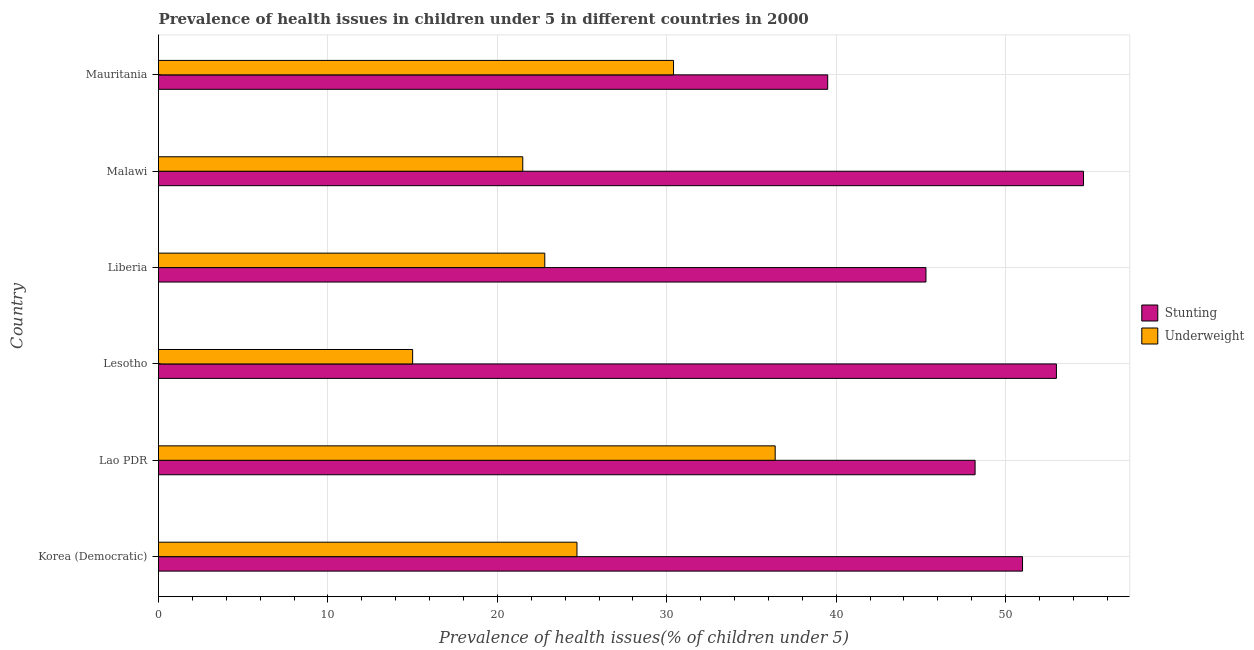How many different coloured bars are there?
Keep it short and to the point. 2. Are the number of bars per tick equal to the number of legend labels?
Offer a terse response. Yes. Are the number of bars on each tick of the Y-axis equal?
Your response must be concise. Yes. How many bars are there on the 4th tick from the bottom?
Offer a terse response. 2. What is the label of the 5th group of bars from the top?
Your answer should be compact. Lao PDR. In how many cases, is the number of bars for a given country not equal to the number of legend labels?
Make the answer very short. 0. What is the percentage of underweight children in Lao PDR?
Your answer should be very brief. 36.4. Across all countries, what is the maximum percentage of underweight children?
Offer a very short reply. 36.4. Across all countries, what is the minimum percentage of stunted children?
Your answer should be compact. 39.5. In which country was the percentage of stunted children maximum?
Give a very brief answer. Malawi. In which country was the percentage of stunted children minimum?
Provide a short and direct response. Mauritania. What is the total percentage of underweight children in the graph?
Your response must be concise. 150.8. What is the difference between the percentage of underweight children in Liberia and that in Malawi?
Your answer should be compact. 1.3. What is the difference between the percentage of underweight children in Lesotho and the percentage of stunted children in Liberia?
Offer a terse response. -30.3. What is the average percentage of stunted children per country?
Your response must be concise. 48.6. What is the difference between the percentage of underweight children and percentage of stunted children in Malawi?
Give a very brief answer. -33.1. In how many countries, is the percentage of stunted children greater than 22 %?
Keep it short and to the point. 6. What is the ratio of the percentage of underweight children in Lesotho to that in Mauritania?
Give a very brief answer. 0.49. What is the difference between the highest and the second highest percentage of underweight children?
Your response must be concise. 6. What is the difference between the highest and the lowest percentage of underweight children?
Ensure brevity in your answer.  21.4. What does the 1st bar from the top in Malawi represents?
Ensure brevity in your answer.  Underweight. What does the 2nd bar from the bottom in Lesotho represents?
Provide a short and direct response. Underweight. How many bars are there?
Keep it short and to the point. 12. Are the values on the major ticks of X-axis written in scientific E-notation?
Provide a succinct answer. No. Does the graph contain grids?
Offer a very short reply. Yes. What is the title of the graph?
Provide a succinct answer. Prevalence of health issues in children under 5 in different countries in 2000. What is the label or title of the X-axis?
Your response must be concise. Prevalence of health issues(% of children under 5). What is the Prevalence of health issues(% of children under 5) in Stunting in Korea (Democratic)?
Your response must be concise. 51. What is the Prevalence of health issues(% of children under 5) in Underweight in Korea (Democratic)?
Give a very brief answer. 24.7. What is the Prevalence of health issues(% of children under 5) in Stunting in Lao PDR?
Ensure brevity in your answer.  48.2. What is the Prevalence of health issues(% of children under 5) in Underweight in Lao PDR?
Your answer should be very brief. 36.4. What is the Prevalence of health issues(% of children under 5) in Stunting in Liberia?
Provide a succinct answer. 45.3. What is the Prevalence of health issues(% of children under 5) in Underweight in Liberia?
Offer a terse response. 22.8. What is the Prevalence of health issues(% of children under 5) in Stunting in Malawi?
Your answer should be compact. 54.6. What is the Prevalence of health issues(% of children under 5) in Stunting in Mauritania?
Provide a succinct answer. 39.5. What is the Prevalence of health issues(% of children under 5) in Underweight in Mauritania?
Make the answer very short. 30.4. Across all countries, what is the maximum Prevalence of health issues(% of children under 5) in Stunting?
Your answer should be compact. 54.6. Across all countries, what is the maximum Prevalence of health issues(% of children under 5) in Underweight?
Keep it short and to the point. 36.4. Across all countries, what is the minimum Prevalence of health issues(% of children under 5) in Stunting?
Provide a short and direct response. 39.5. Across all countries, what is the minimum Prevalence of health issues(% of children under 5) in Underweight?
Provide a short and direct response. 15. What is the total Prevalence of health issues(% of children under 5) of Stunting in the graph?
Give a very brief answer. 291.6. What is the total Prevalence of health issues(% of children under 5) in Underweight in the graph?
Offer a terse response. 150.8. What is the difference between the Prevalence of health issues(% of children under 5) of Stunting in Korea (Democratic) and that in Lao PDR?
Keep it short and to the point. 2.8. What is the difference between the Prevalence of health issues(% of children under 5) of Underweight in Korea (Democratic) and that in Lao PDR?
Your answer should be very brief. -11.7. What is the difference between the Prevalence of health issues(% of children under 5) of Underweight in Korea (Democratic) and that in Liberia?
Give a very brief answer. 1.9. What is the difference between the Prevalence of health issues(% of children under 5) in Stunting in Korea (Democratic) and that in Malawi?
Provide a short and direct response. -3.6. What is the difference between the Prevalence of health issues(% of children under 5) in Underweight in Lao PDR and that in Lesotho?
Ensure brevity in your answer.  21.4. What is the difference between the Prevalence of health issues(% of children under 5) of Stunting in Lao PDR and that in Liberia?
Your answer should be very brief. 2.9. What is the difference between the Prevalence of health issues(% of children under 5) in Underweight in Lao PDR and that in Malawi?
Ensure brevity in your answer.  14.9. What is the difference between the Prevalence of health issues(% of children under 5) of Underweight in Lao PDR and that in Mauritania?
Keep it short and to the point. 6. What is the difference between the Prevalence of health issues(% of children under 5) of Stunting in Lesotho and that in Liberia?
Offer a very short reply. 7.7. What is the difference between the Prevalence of health issues(% of children under 5) in Stunting in Lesotho and that in Malawi?
Offer a terse response. -1.6. What is the difference between the Prevalence of health issues(% of children under 5) of Stunting in Lesotho and that in Mauritania?
Provide a short and direct response. 13.5. What is the difference between the Prevalence of health issues(% of children under 5) in Underweight in Lesotho and that in Mauritania?
Provide a short and direct response. -15.4. What is the difference between the Prevalence of health issues(% of children under 5) in Underweight in Liberia and that in Malawi?
Offer a terse response. 1.3. What is the difference between the Prevalence of health issues(% of children under 5) in Stunting in Korea (Democratic) and the Prevalence of health issues(% of children under 5) in Underweight in Lao PDR?
Your response must be concise. 14.6. What is the difference between the Prevalence of health issues(% of children under 5) of Stunting in Korea (Democratic) and the Prevalence of health issues(% of children under 5) of Underweight in Lesotho?
Your response must be concise. 36. What is the difference between the Prevalence of health issues(% of children under 5) in Stunting in Korea (Democratic) and the Prevalence of health issues(% of children under 5) in Underweight in Liberia?
Your response must be concise. 28.2. What is the difference between the Prevalence of health issues(% of children under 5) of Stunting in Korea (Democratic) and the Prevalence of health issues(% of children under 5) of Underweight in Malawi?
Provide a short and direct response. 29.5. What is the difference between the Prevalence of health issues(% of children under 5) in Stunting in Korea (Democratic) and the Prevalence of health issues(% of children under 5) in Underweight in Mauritania?
Keep it short and to the point. 20.6. What is the difference between the Prevalence of health issues(% of children under 5) in Stunting in Lao PDR and the Prevalence of health issues(% of children under 5) in Underweight in Lesotho?
Offer a terse response. 33.2. What is the difference between the Prevalence of health issues(% of children under 5) in Stunting in Lao PDR and the Prevalence of health issues(% of children under 5) in Underweight in Liberia?
Offer a very short reply. 25.4. What is the difference between the Prevalence of health issues(% of children under 5) in Stunting in Lao PDR and the Prevalence of health issues(% of children under 5) in Underweight in Malawi?
Your response must be concise. 26.7. What is the difference between the Prevalence of health issues(% of children under 5) of Stunting in Lesotho and the Prevalence of health issues(% of children under 5) of Underweight in Liberia?
Provide a succinct answer. 30.2. What is the difference between the Prevalence of health issues(% of children under 5) of Stunting in Lesotho and the Prevalence of health issues(% of children under 5) of Underweight in Malawi?
Provide a succinct answer. 31.5. What is the difference between the Prevalence of health issues(% of children under 5) of Stunting in Lesotho and the Prevalence of health issues(% of children under 5) of Underweight in Mauritania?
Keep it short and to the point. 22.6. What is the difference between the Prevalence of health issues(% of children under 5) in Stunting in Liberia and the Prevalence of health issues(% of children under 5) in Underweight in Malawi?
Offer a terse response. 23.8. What is the difference between the Prevalence of health issues(% of children under 5) in Stunting in Malawi and the Prevalence of health issues(% of children under 5) in Underweight in Mauritania?
Your response must be concise. 24.2. What is the average Prevalence of health issues(% of children under 5) of Stunting per country?
Give a very brief answer. 48.6. What is the average Prevalence of health issues(% of children under 5) of Underweight per country?
Keep it short and to the point. 25.13. What is the difference between the Prevalence of health issues(% of children under 5) of Stunting and Prevalence of health issues(% of children under 5) of Underweight in Korea (Democratic)?
Keep it short and to the point. 26.3. What is the difference between the Prevalence of health issues(% of children under 5) of Stunting and Prevalence of health issues(% of children under 5) of Underweight in Lao PDR?
Your answer should be very brief. 11.8. What is the difference between the Prevalence of health issues(% of children under 5) of Stunting and Prevalence of health issues(% of children under 5) of Underweight in Liberia?
Provide a short and direct response. 22.5. What is the difference between the Prevalence of health issues(% of children under 5) in Stunting and Prevalence of health issues(% of children under 5) in Underweight in Malawi?
Your response must be concise. 33.1. What is the ratio of the Prevalence of health issues(% of children under 5) in Stunting in Korea (Democratic) to that in Lao PDR?
Keep it short and to the point. 1.06. What is the ratio of the Prevalence of health issues(% of children under 5) in Underweight in Korea (Democratic) to that in Lao PDR?
Provide a succinct answer. 0.68. What is the ratio of the Prevalence of health issues(% of children under 5) of Stunting in Korea (Democratic) to that in Lesotho?
Ensure brevity in your answer.  0.96. What is the ratio of the Prevalence of health issues(% of children under 5) in Underweight in Korea (Democratic) to that in Lesotho?
Your answer should be very brief. 1.65. What is the ratio of the Prevalence of health issues(% of children under 5) in Stunting in Korea (Democratic) to that in Liberia?
Ensure brevity in your answer.  1.13. What is the ratio of the Prevalence of health issues(% of children under 5) in Underweight in Korea (Democratic) to that in Liberia?
Provide a short and direct response. 1.08. What is the ratio of the Prevalence of health issues(% of children under 5) of Stunting in Korea (Democratic) to that in Malawi?
Offer a very short reply. 0.93. What is the ratio of the Prevalence of health issues(% of children under 5) of Underweight in Korea (Democratic) to that in Malawi?
Provide a short and direct response. 1.15. What is the ratio of the Prevalence of health issues(% of children under 5) in Stunting in Korea (Democratic) to that in Mauritania?
Make the answer very short. 1.29. What is the ratio of the Prevalence of health issues(% of children under 5) of Underweight in Korea (Democratic) to that in Mauritania?
Your answer should be compact. 0.81. What is the ratio of the Prevalence of health issues(% of children under 5) of Stunting in Lao PDR to that in Lesotho?
Offer a terse response. 0.91. What is the ratio of the Prevalence of health issues(% of children under 5) in Underweight in Lao PDR to that in Lesotho?
Provide a short and direct response. 2.43. What is the ratio of the Prevalence of health issues(% of children under 5) of Stunting in Lao PDR to that in Liberia?
Your response must be concise. 1.06. What is the ratio of the Prevalence of health issues(% of children under 5) in Underweight in Lao PDR to that in Liberia?
Ensure brevity in your answer.  1.6. What is the ratio of the Prevalence of health issues(% of children under 5) of Stunting in Lao PDR to that in Malawi?
Offer a terse response. 0.88. What is the ratio of the Prevalence of health issues(% of children under 5) in Underweight in Lao PDR to that in Malawi?
Keep it short and to the point. 1.69. What is the ratio of the Prevalence of health issues(% of children under 5) of Stunting in Lao PDR to that in Mauritania?
Give a very brief answer. 1.22. What is the ratio of the Prevalence of health issues(% of children under 5) of Underweight in Lao PDR to that in Mauritania?
Provide a short and direct response. 1.2. What is the ratio of the Prevalence of health issues(% of children under 5) of Stunting in Lesotho to that in Liberia?
Give a very brief answer. 1.17. What is the ratio of the Prevalence of health issues(% of children under 5) of Underweight in Lesotho to that in Liberia?
Your answer should be very brief. 0.66. What is the ratio of the Prevalence of health issues(% of children under 5) of Stunting in Lesotho to that in Malawi?
Make the answer very short. 0.97. What is the ratio of the Prevalence of health issues(% of children under 5) of Underweight in Lesotho to that in Malawi?
Give a very brief answer. 0.7. What is the ratio of the Prevalence of health issues(% of children under 5) of Stunting in Lesotho to that in Mauritania?
Your answer should be very brief. 1.34. What is the ratio of the Prevalence of health issues(% of children under 5) of Underweight in Lesotho to that in Mauritania?
Your answer should be very brief. 0.49. What is the ratio of the Prevalence of health issues(% of children under 5) in Stunting in Liberia to that in Malawi?
Ensure brevity in your answer.  0.83. What is the ratio of the Prevalence of health issues(% of children under 5) in Underweight in Liberia to that in Malawi?
Ensure brevity in your answer.  1.06. What is the ratio of the Prevalence of health issues(% of children under 5) of Stunting in Liberia to that in Mauritania?
Make the answer very short. 1.15. What is the ratio of the Prevalence of health issues(% of children under 5) in Underweight in Liberia to that in Mauritania?
Offer a terse response. 0.75. What is the ratio of the Prevalence of health issues(% of children under 5) in Stunting in Malawi to that in Mauritania?
Provide a succinct answer. 1.38. What is the ratio of the Prevalence of health issues(% of children under 5) in Underweight in Malawi to that in Mauritania?
Ensure brevity in your answer.  0.71. What is the difference between the highest and the second highest Prevalence of health issues(% of children under 5) of Stunting?
Your response must be concise. 1.6. What is the difference between the highest and the second highest Prevalence of health issues(% of children under 5) of Underweight?
Give a very brief answer. 6. What is the difference between the highest and the lowest Prevalence of health issues(% of children under 5) in Underweight?
Provide a succinct answer. 21.4. 